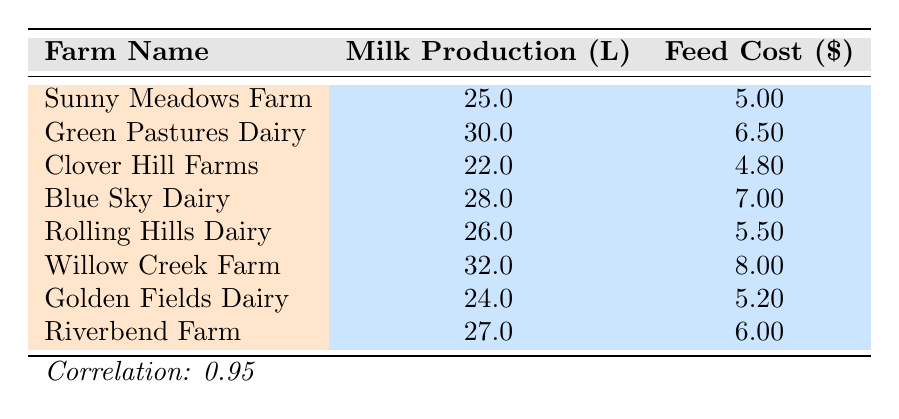What is the milk production per cow for Willow Creek Farm? According to the table, the row for Willow Creek Farm shows a milk production of 32 liters per cow.
Answer: 32 liters What is the feed cost per cow for Clover Hill Farms? The table displays Clover Hill Farms with a feed cost of 4.80 USD per cow.
Answer: 4.80 USD Which farm has the lowest feed cost per cow? By comparing the feed costs listed, Clover Hill Farms has the lowest cost at 4.80 USD per cow.
Answer: Clover Hill Farms What is the total milk production per cow for Sunny Meadows Farm and Golden Fields Dairy combined? The milk production for Sunny Meadows Farm is 25 liters and for Golden Fields Dairy is 24 liters. Adding them gives 25 + 24 = 49 liters as the total.
Answer: 49 liters Is it true that Blue Sky Dairy has a higher feed cost than Green Pastures Dairy? Blue Sky Dairy has a feed cost of 7.00 USD, while Green Pastures Dairy has 6.50 USD. Thus, Blue Sky Dairy does not have a higher feed cost.
Answer: No Which farm has the highest milk production per cow? By reviewing the table, Willow Creek Farm has the highest milk production at 32 liters per cow.
Answer: Willow Creek Farm What is the correlation between milk production and feed cost in this dataset? The table states that the correlation between milk production and feed cost is 0.95, indicating a strong positive relationship.
Answer: 0.95 How many farms have a feed cost greater than 6 USD? By assessing the feed costs in the table, Green Pastures Dairy, Blue Sky Dairy, and Willow Creek Farm all have costs over 6 USD, totaling three farms.
Answer: 3 farms What is the average milk production per cow for all farms listed? Adding all milk production values (25 + 30 + 22 + 28 + 26 + 32 + 24 + 27 = 224) gives 224 liters. Dividing by the number of farms (8), the average is 28 liters per cow.
Answer: 28 liters 